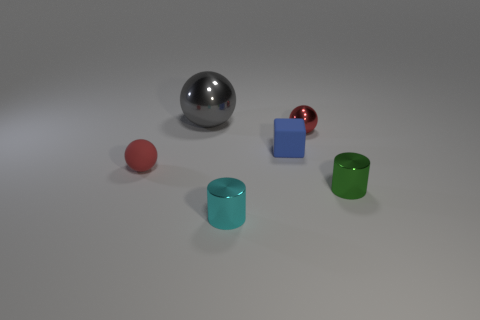Add 4 small red shiny cubes. How many objects exist? 10 Subtract all cylinders. How many objects are left? 4 Subtract all rubber blocks. Subtract all metallic balls. How many objects are left? 3 Add 4 rubber blocks. How many rubber blocks are left? 5 Add 5 red matte objects. How many red matte objects exist? 6 Subtract 0 purple spheres. How many objects are left? 6 